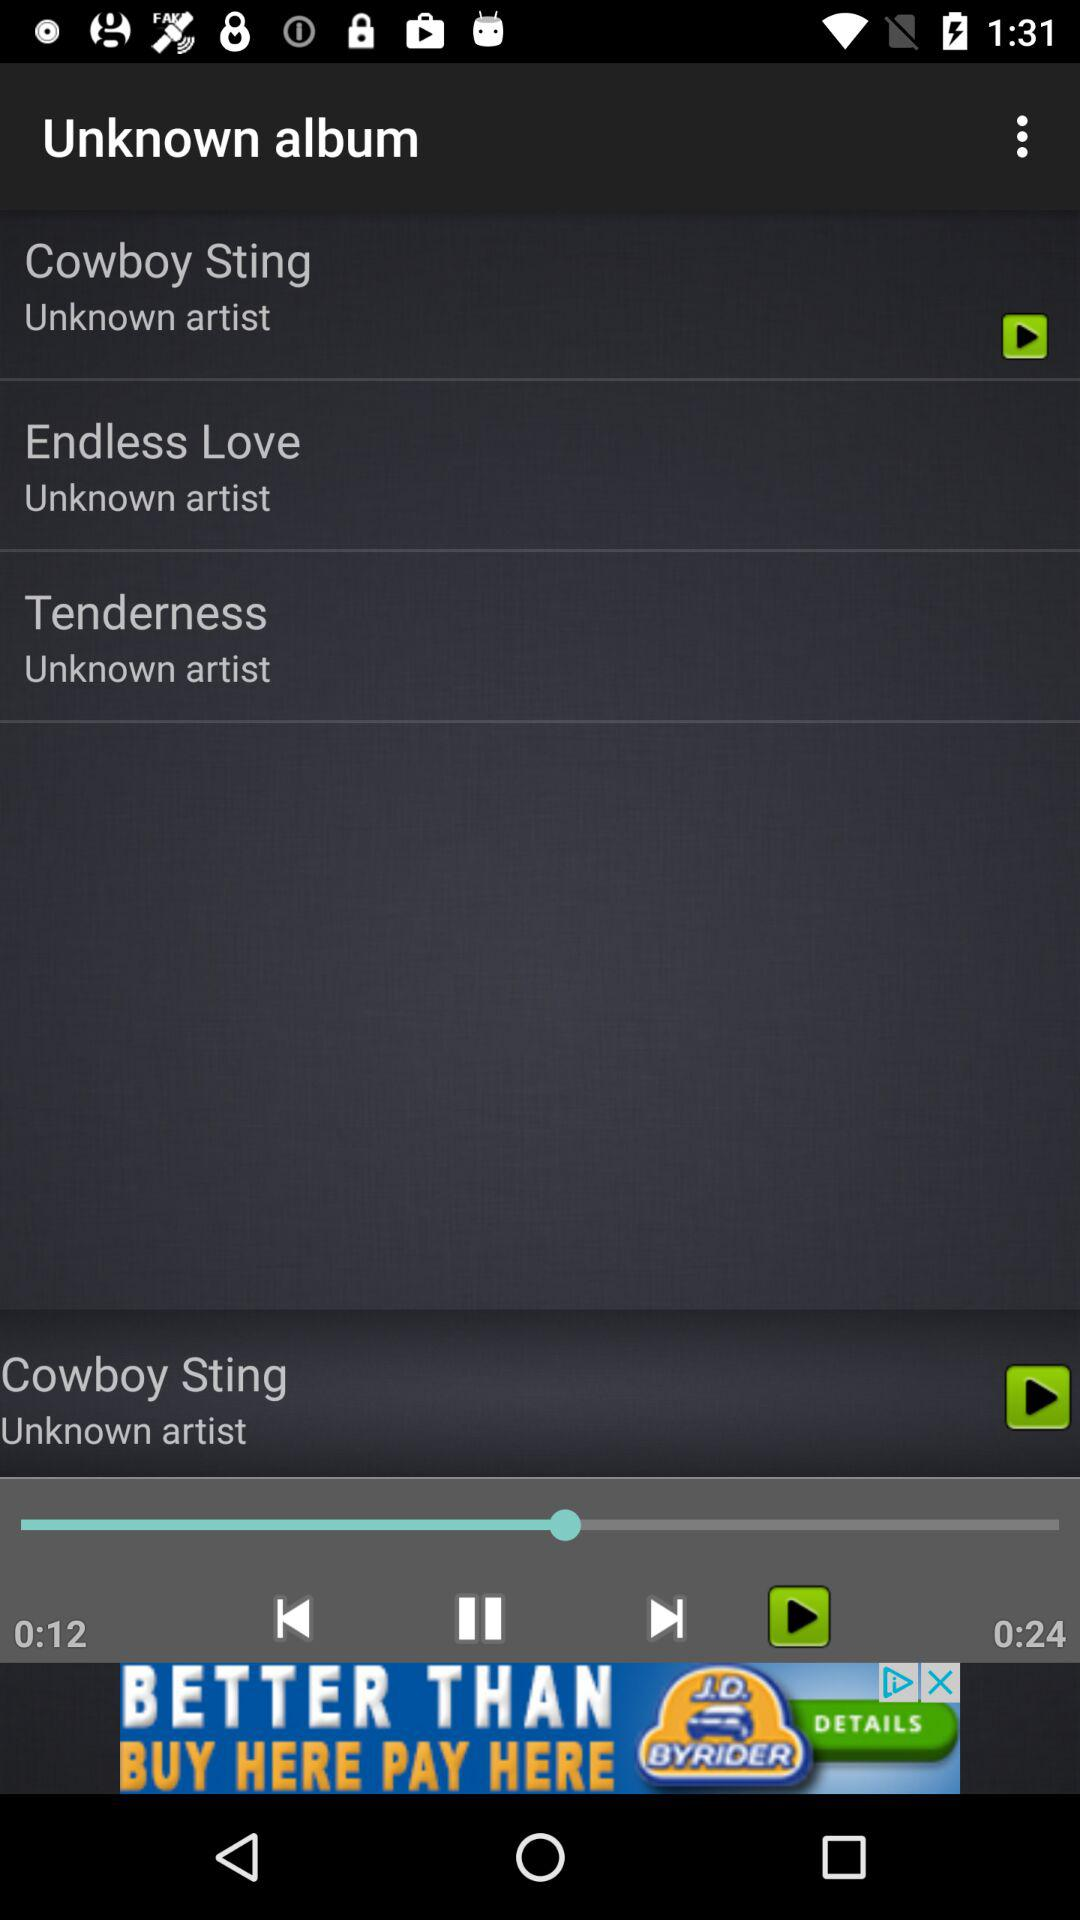How many seconds are left in the current song?
Answer the question using a single word or phrase. 12 